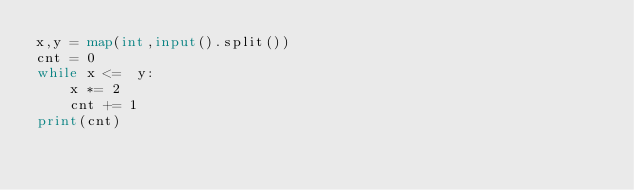<code> <loc_0><loc_0><loc_500><loc_500><_Python_>x,y = map(int,input().split())
cnt = 0
while x <=  y:
    x *= 2
    cnt += 1
print(cnt)</code> 